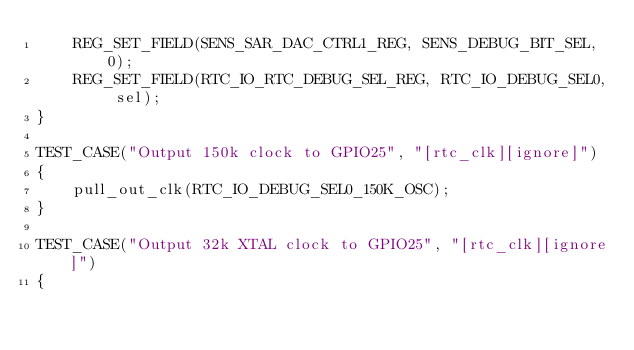Convert code to text. <code><loc_0><loc_0><loc_500><loc_500><_C_>    REG_SET_FIELD(SENS_SAR_DAC_CTRL1_REG, SENS_DEBUG_BIT_SEL, 0);
    REG_SET_FIELD(RTC_IO_RTC_DEBUG_SEL_REG, RTC_IO_DEBUG_SEL0, sel);
}

TEST_CASE("Output 150k clock to GPIO25", "[rtc_clk][ignore]")
{
    pull_out_clk(RTC_IO_DEBUG_SEL0_150K_OSC);
}

TEST_CASE("Output 32k XTAL clock to GPIO25", "[rtc_clk][ignore]")
{</code> 